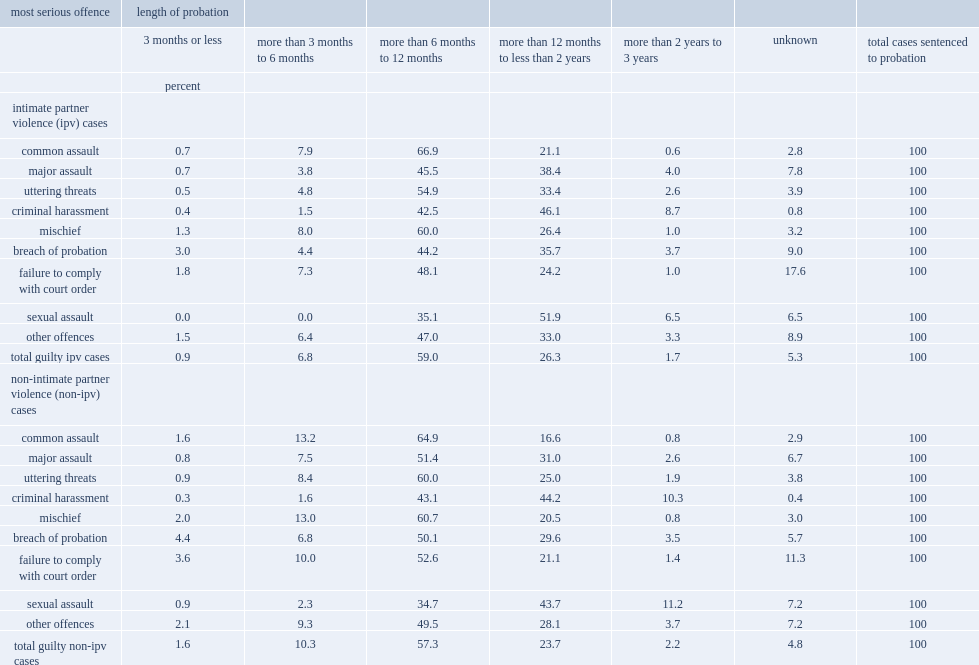As with custody sentences, what are the top two cases resulted in the longest probation sentences for those convicted in ipv cases and in non-ipv cases? Criminal harassment sexual assault. 